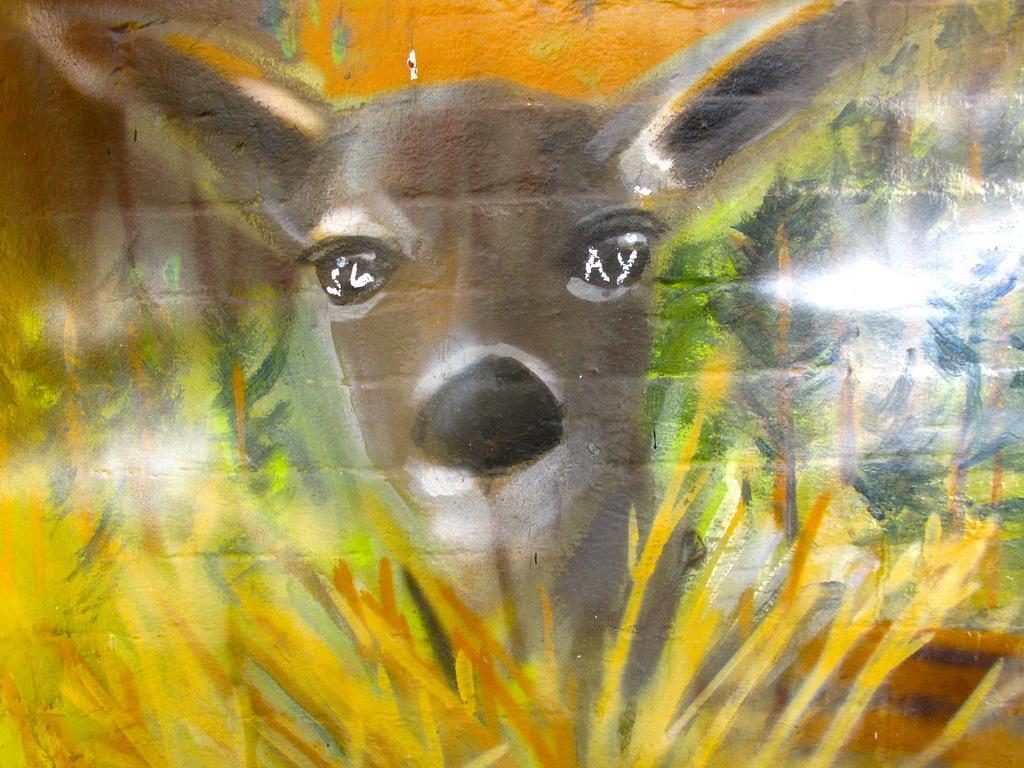How would you summarize this image in a sentence or two? In this image there is a painting of deer and trees on the wall. 